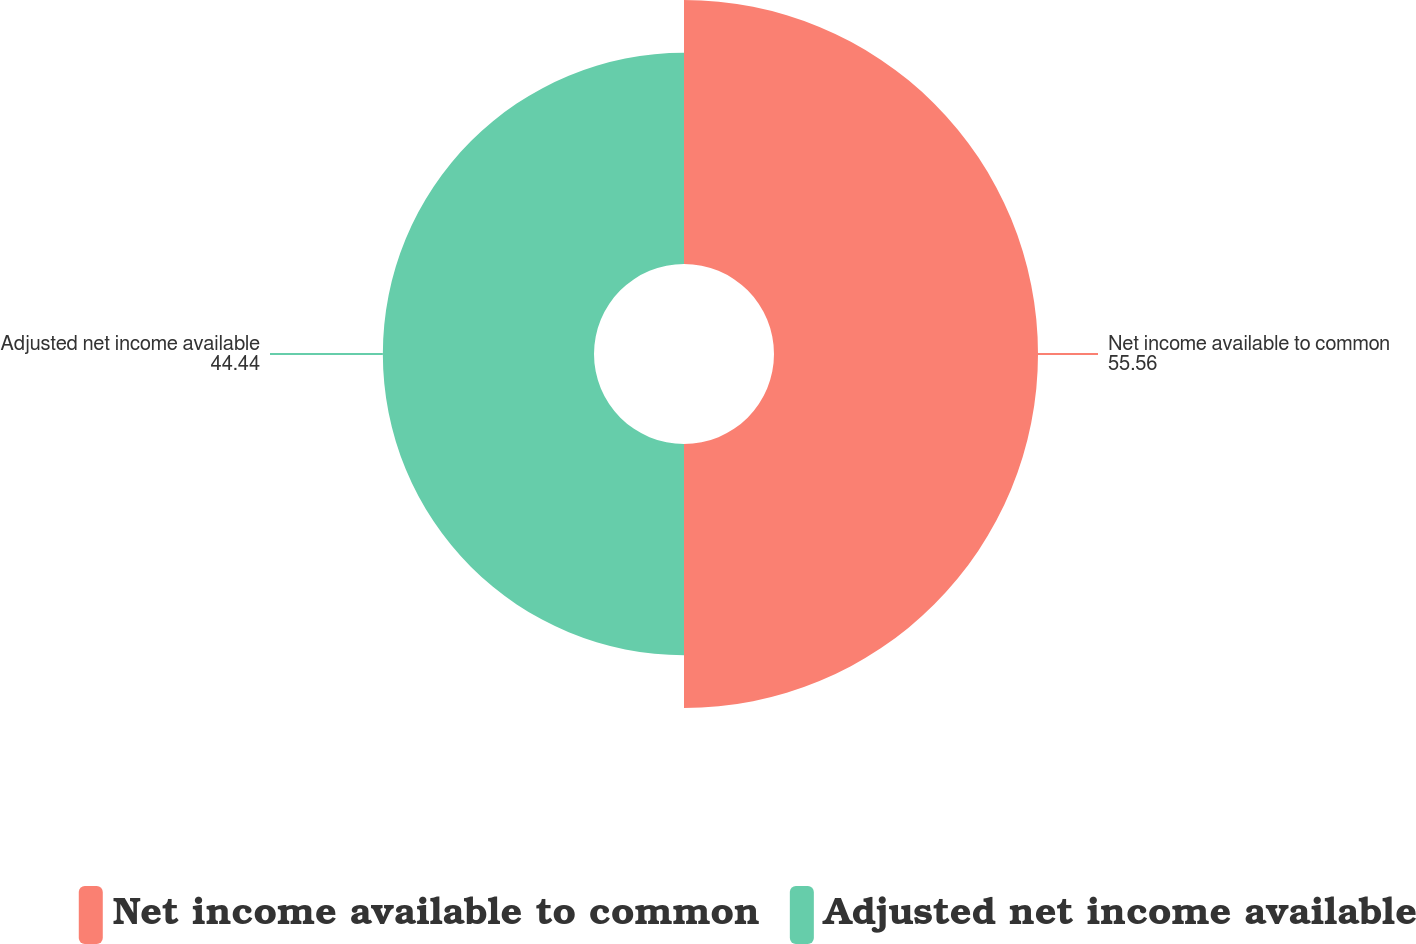Convert chart. <chart><loc_0><loc_0><loc_500><loc_500><pie_chart><fcel>Net income available to common<fcel>Adjusted net income available<nl><fcel>55.56%<fcel>44.44%<nl></chart> 